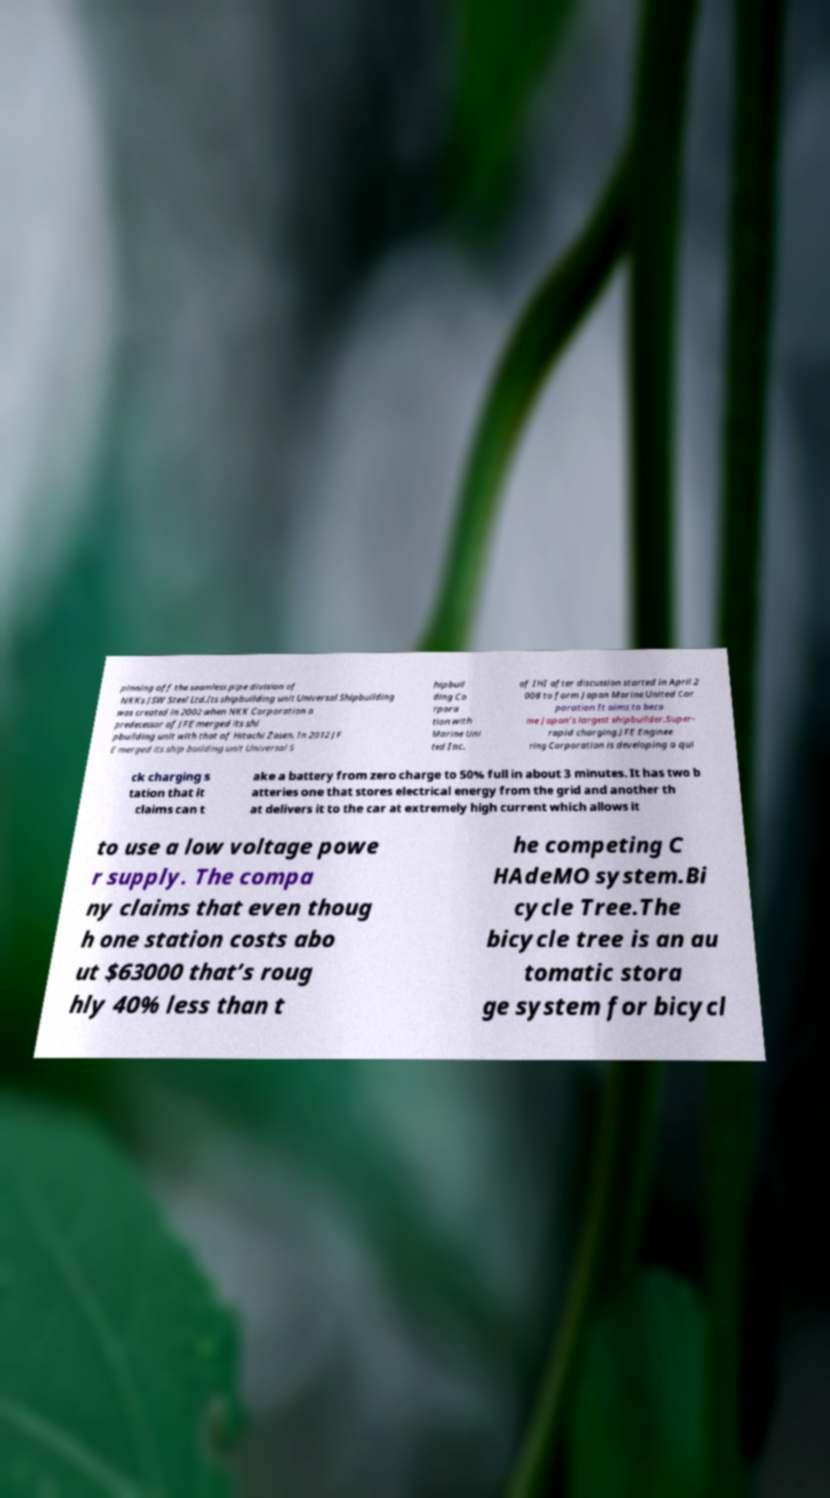Could you assist in decoding the text presented in this image and type it out clearly? pinning off the seamless pipe division of NKKs JSW Steel Ltd.Its shipbuilding unit Universal Shipbuilding was created in 2002 when NKK Corporation a predecessor of JFE merged its shi pbuilding unit with that of Hitachi Zosen. In 2012 JF E merged its ship building unit Universal S hipbuil ding Co rpora tion with Marine Uni ted Inc. of IHI after discussion started in April 2 008 to form Japan Marine United Cor poration It aims to beco me Japan’s largest shipbuilder.Super- rapid charging.JFE Enginee ring Corporation is developing a qui ck charging s tation that it claims can t ake a battery from zero charge to 50% full in about 3 minutes. It has two b atteries one that stores electrical energy from the grid and another th at delivers it to the car at extremely high current which allows it to use a low voltage powe r supply. The compa ny claims that even thoug h one station costs abo ut $63000 that’s roug hly 40% less than t he competing C HAdeMO system.Bi cycle Tree.The bicycle tree is an au tomatic stora ge system for bicycl 